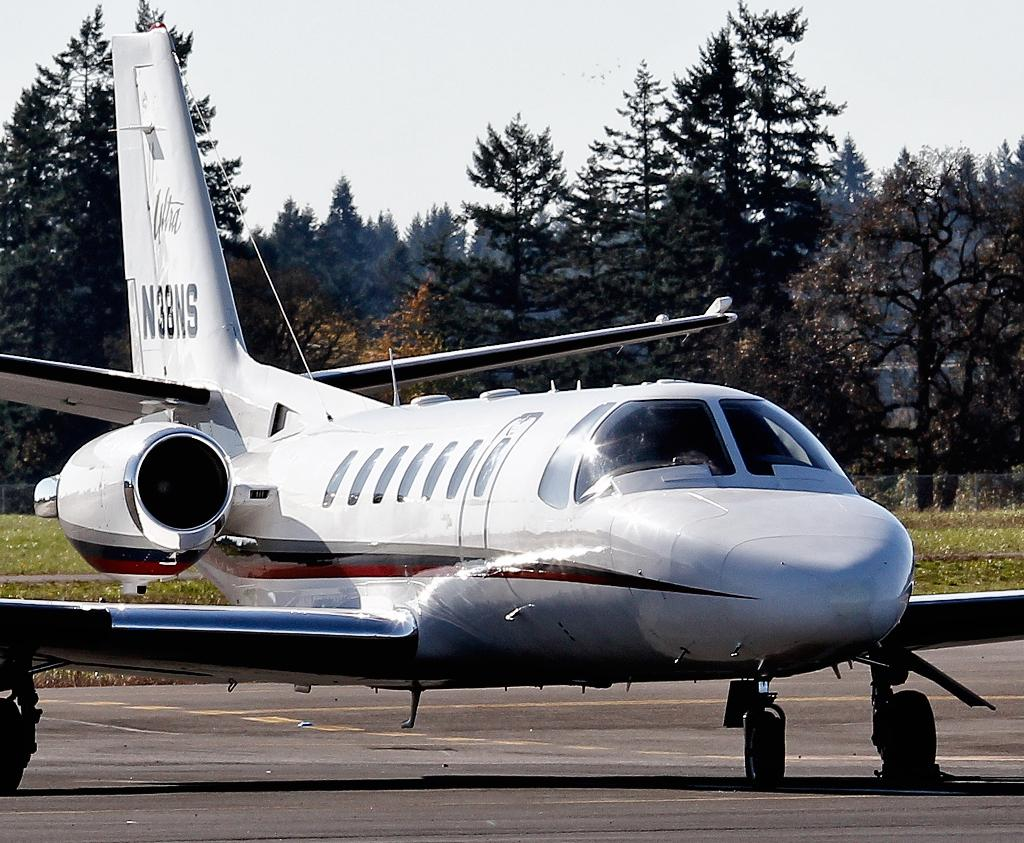Provide a one-sentence caption for the provided image. a plane parked on a runway with N3BNS on the tail. 